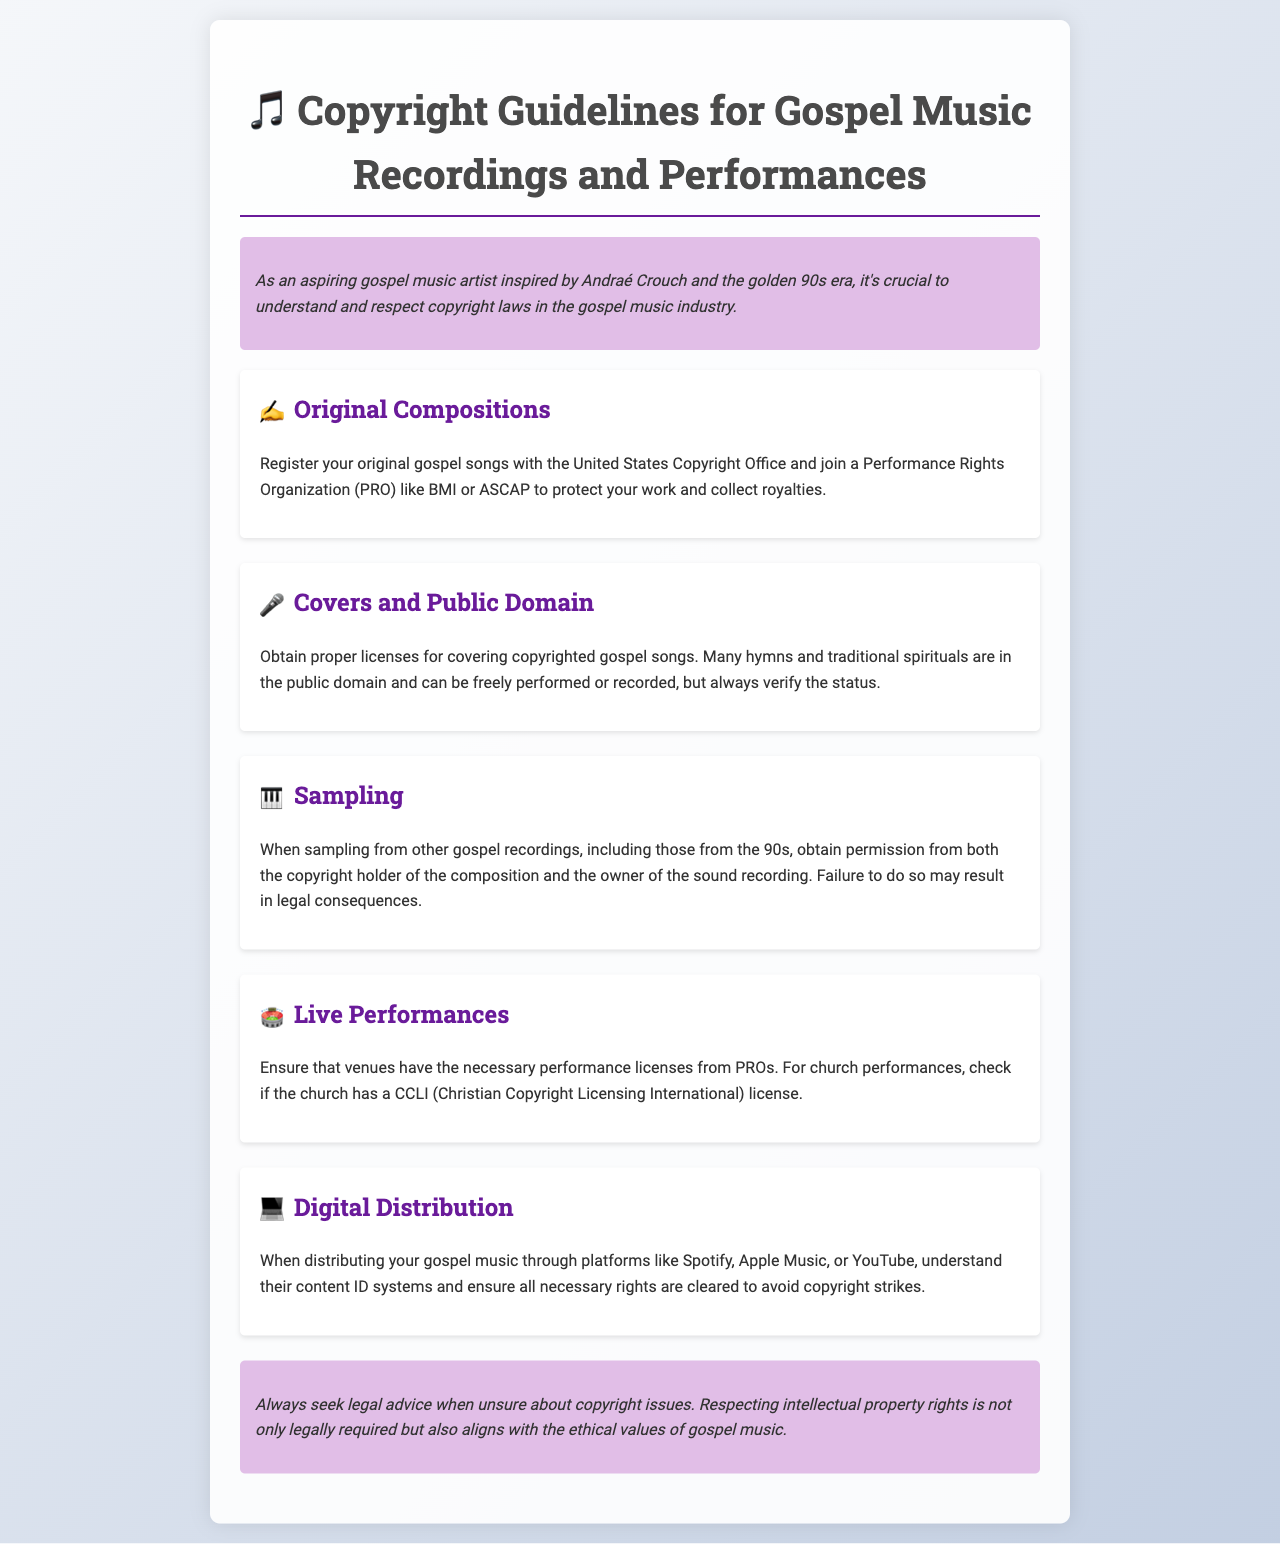What should you do with your original gospel songs? You should register them with the United States Copyright Office and join a Performance Rights Organization to protect your work and collect royalties.
Answer: Register with the United States Copyright Office What do you need to obtain for covering copyrighted gospel songs? Proper licenses are required for covering copyrighted gospel songs.
Answer: Proper licenses What may be required when sampling gospel music? You must obtain permission from both the copyright holder of the composition and the owner of the sound recording when sampling.
Answer: Obtain permission What is a necessary check for live performances at churches? Check if the church has a CCLI license for performances.
Answer: CCLI license Which platforms require understanding of content ID systems for distribution? Platforms like Spotify, Apple Music, or YouTube require this understanding for digital distribution.
Answer: Spotify, Apple Music, or YouTube What ethical consideration is mentioned in the conclusion regarding copyright? Respecting intellectual property rights aligns with the ethical values of gospel music.
Answer: Ethical values of gospel music What organization can help with performance rights? You can join a Performance Rights Organization like BMI or ASCAP for assistance.
Answer: BMI or ASCAP Which types of songs are typically in the public domain? Many hymns and traditional spirituals are considered to be in the public domain.
Answer: Hymns and traditional spirituals 